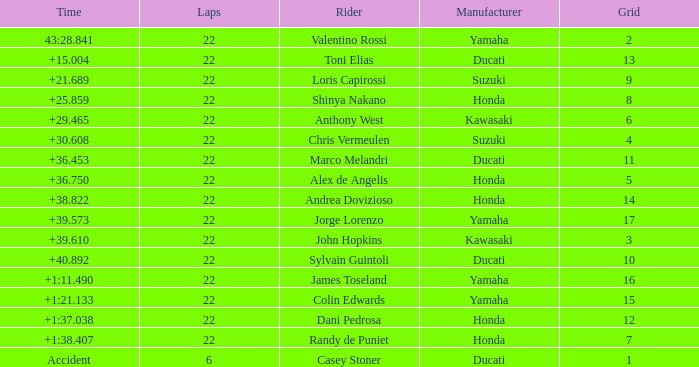Who had the lowest laps on a grid smaller than 16 with a time of +21.689? 22.0. 